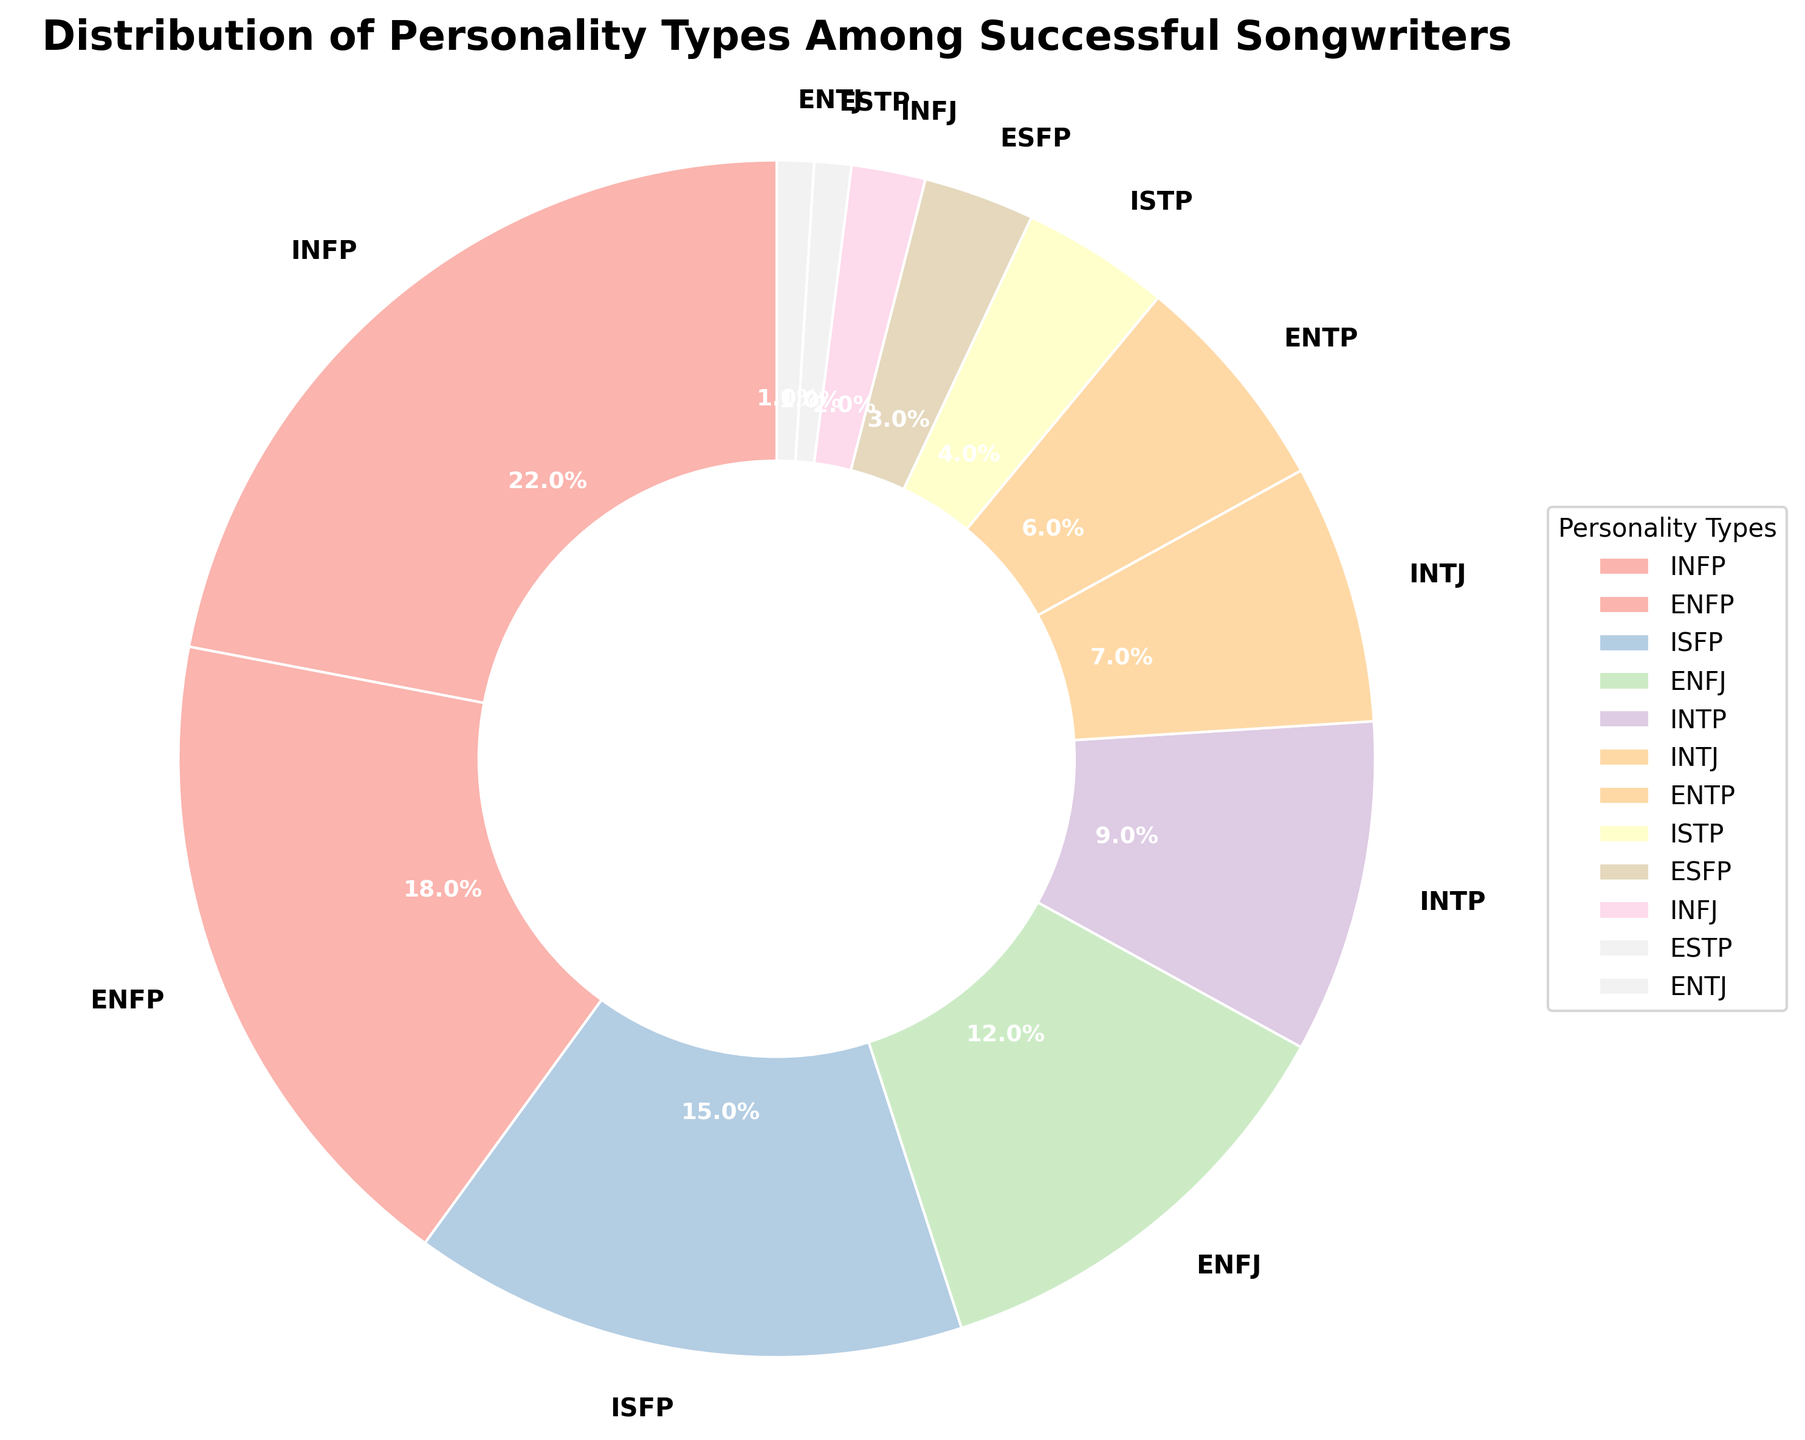Which personality type is the most common among successful songwriters? The figure shows a pie chart with different sized wedges representing the percentage of each personality type. The largest wedge corresponds to INFP.
Answer: INFP Which two personality types have the smallest representation among successful songwriters? The pie chart indicates the relative sizes of each segment. The smallest wedges, representing the least common personality types, are ESTP and ENTJ.
Answer: ESTP and ENTJ By how much does the percentage of ENFPs exceed that of INTPs? The percentage for ENFPs is 18%, and for INTPs, it is 9%. The difference can be calculated as 18 - 9.
Answer: 9% What is the combined percentage of ISFP and ENFJ personality types? The figure shows the percentages for ISFP as 15% and ENFJ as 12%. Adding these two values gives the combined percentage.
Answer: 27% Is the percentage of INFJs higher or lower than 5%? The pie chart indicates the percentage for INFJ is 2%, which is lower than 5%.
Answer: Lower Which personality type is represented by a green-colored segment on the pie chart? The color coding in the pie chart matches specific personality types. The segment colored green corresponds to the INFP personality type.
Answer: INFP What is the difference in percentage between the most and least common personality types? The most common type (INFP) is 22%, and the least common types (ESTP and ENTJ) are each 1%. The difference is calculated as 22 - 1.
Answer: 21% How does the percentage of INTJ compare to that of ENTP? The pie chart shows the percentage for INTJ as 7% and for ENTP as 6%. Comparing these values, INTJ is higher.
Answer: INTJ is higher Which segment, representing personality types, is halfway between the smallest and largest in size according to the chart? The largest segment is INFP (22%), and the smallest segments are ESTP and ENTJ (each 1%). Halfway between would be roughly 11.5%, resembling ENFJ at 12%.
Answer: ENFJ Identify a personality type that has a representation close to the average percentage of all types presented. Summing all percentages: 22 + 18 + 15 + 12 + 9 + 7 + 6 + 4 + 3 + 2 + 1 + 1 = 100. The average is 100 / 12 ≈ 8.3%. INTP at 9% is closest to this average.
Answer: INTP 